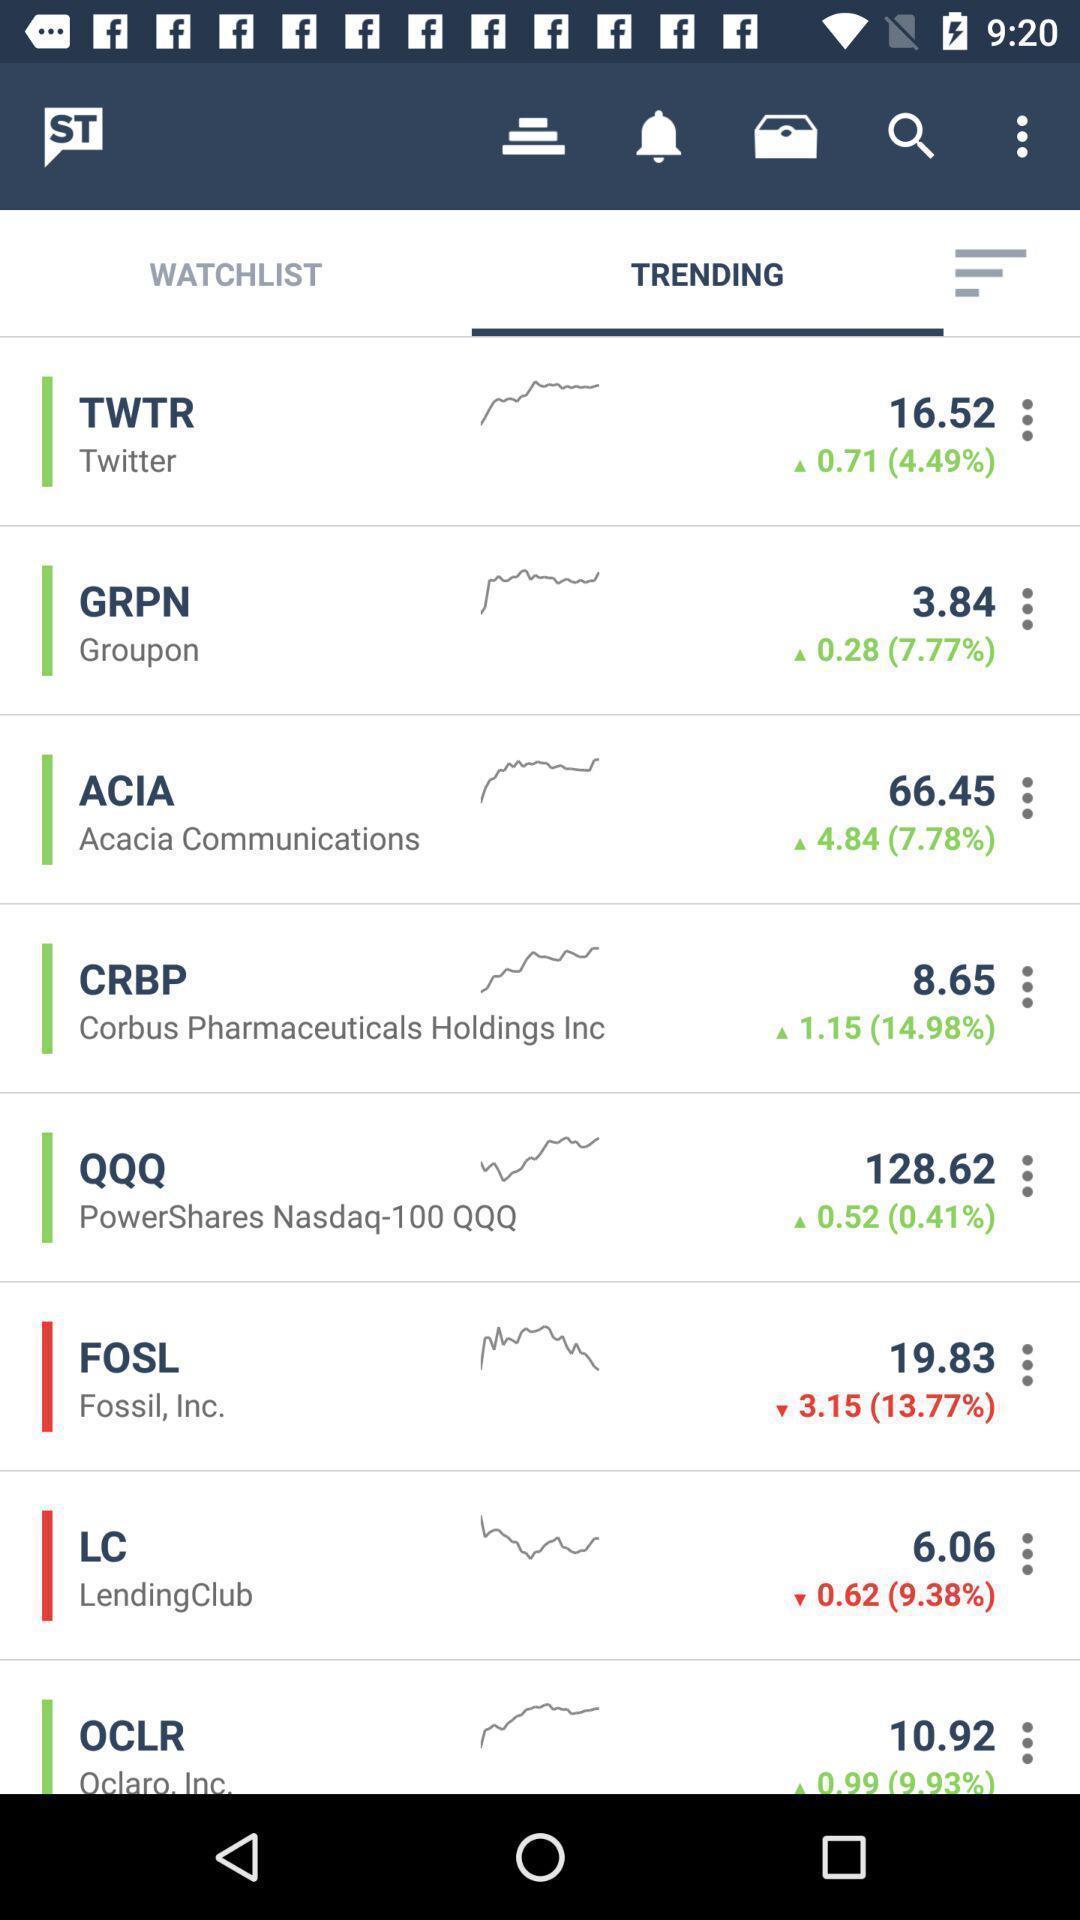Please provide a description for this image. Page showing list of trending apps. 